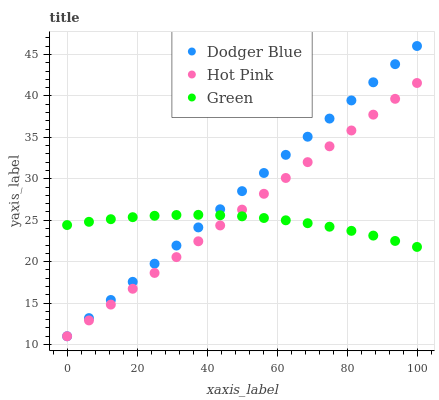Does Green have the minimum area under the curve?
Answer yes or no. Yes. Does Dodger Blue have the maximum area under the curve?
Answer yes or no. Yes. Does Hot Pink have the minimum area under the curve?
Answer yes or no. No. Does Hot Pink have the maximum area under the curve?
Answer yes or no. No. Is Hot Pink the smoothest?
Answer yes or no. Yes. Is Green the roughest?
Answer yes or no. Yes. Is Dodger Blue the smoothest?
Answer yes or no. No. Is Dodger Blue the roughest?
Answer yes or no. No. Does Hot Pink have the lowest value?
Answer yes or no. Yes. Does Dodger Blue have the highest value?
Answer yes or no. Yes. Does Hot Pink have the highest value?
Answer yes or no. No. Does Green intersect Dodger Blue?
Answer yes or no. Yes. Is Green less than Dodger Blue?
Answer yes or no. No. Is Green greater than Dodger Blue?
Answer yes or no. No. 